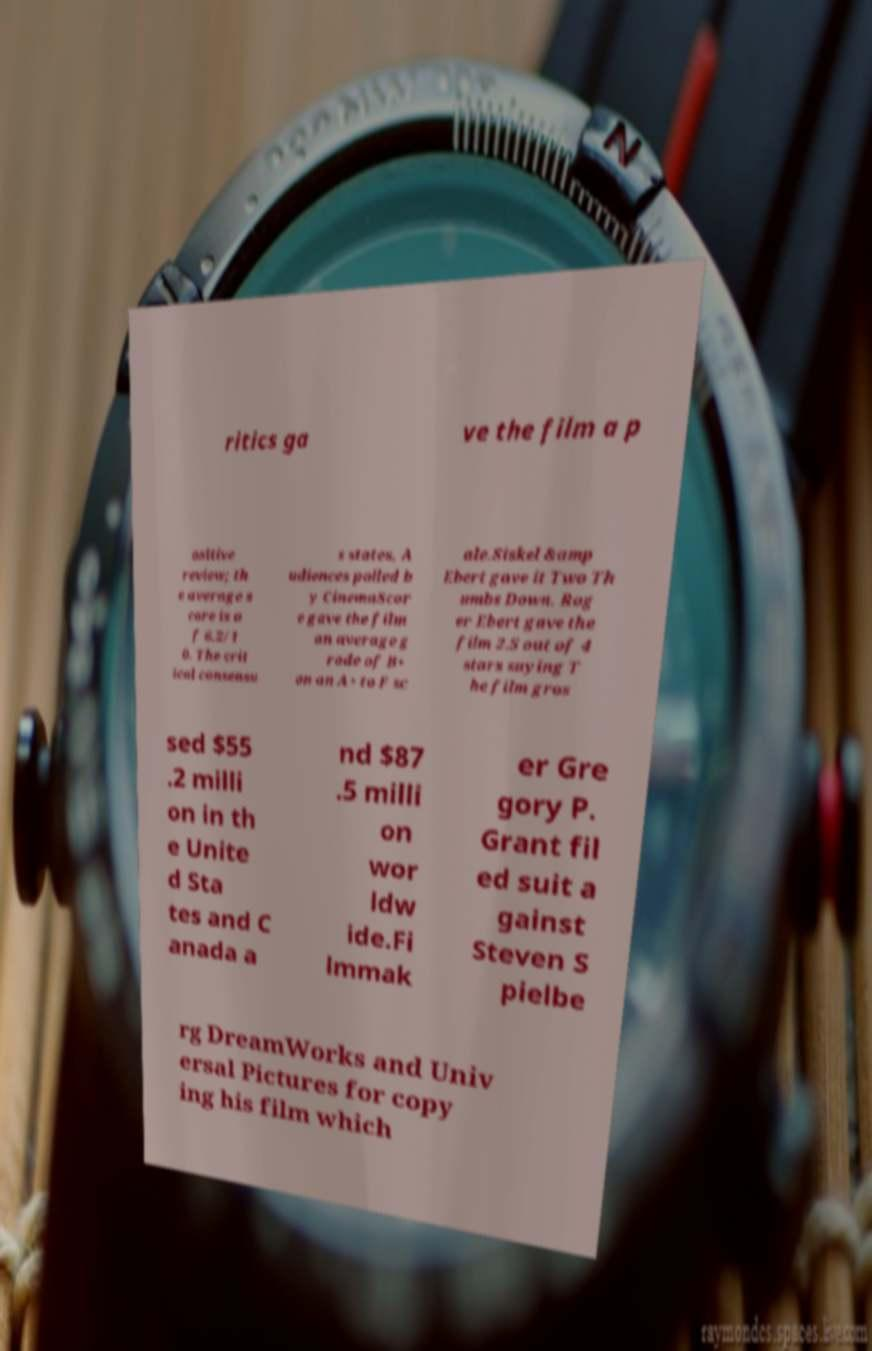I need the written content from this picture converted into text. Can you do that? ritics ga ve the film a p ositive review; th e average s core is o f 6.2/1 0. The crit ical consensu s states, A udiences polled b y CinemaScor e gave the film an average g rade of B+ on an A+ to F sc ale.Siskel &amp Ebert gave it Two Th umbs Down. Rog er Ebert gave the film 2.5 out of 4 stars saying T he film gros sed $55 .2 milli on in th e Unite d Sta tes and C anada a nd $87 .5 milli on wor ldw ide.Fi lmmak er Gre gory P. Grant fil ed suit a gainst Steven S pielbe rg DreamWorks and Univ ersal Pictures for copy ing his film which 